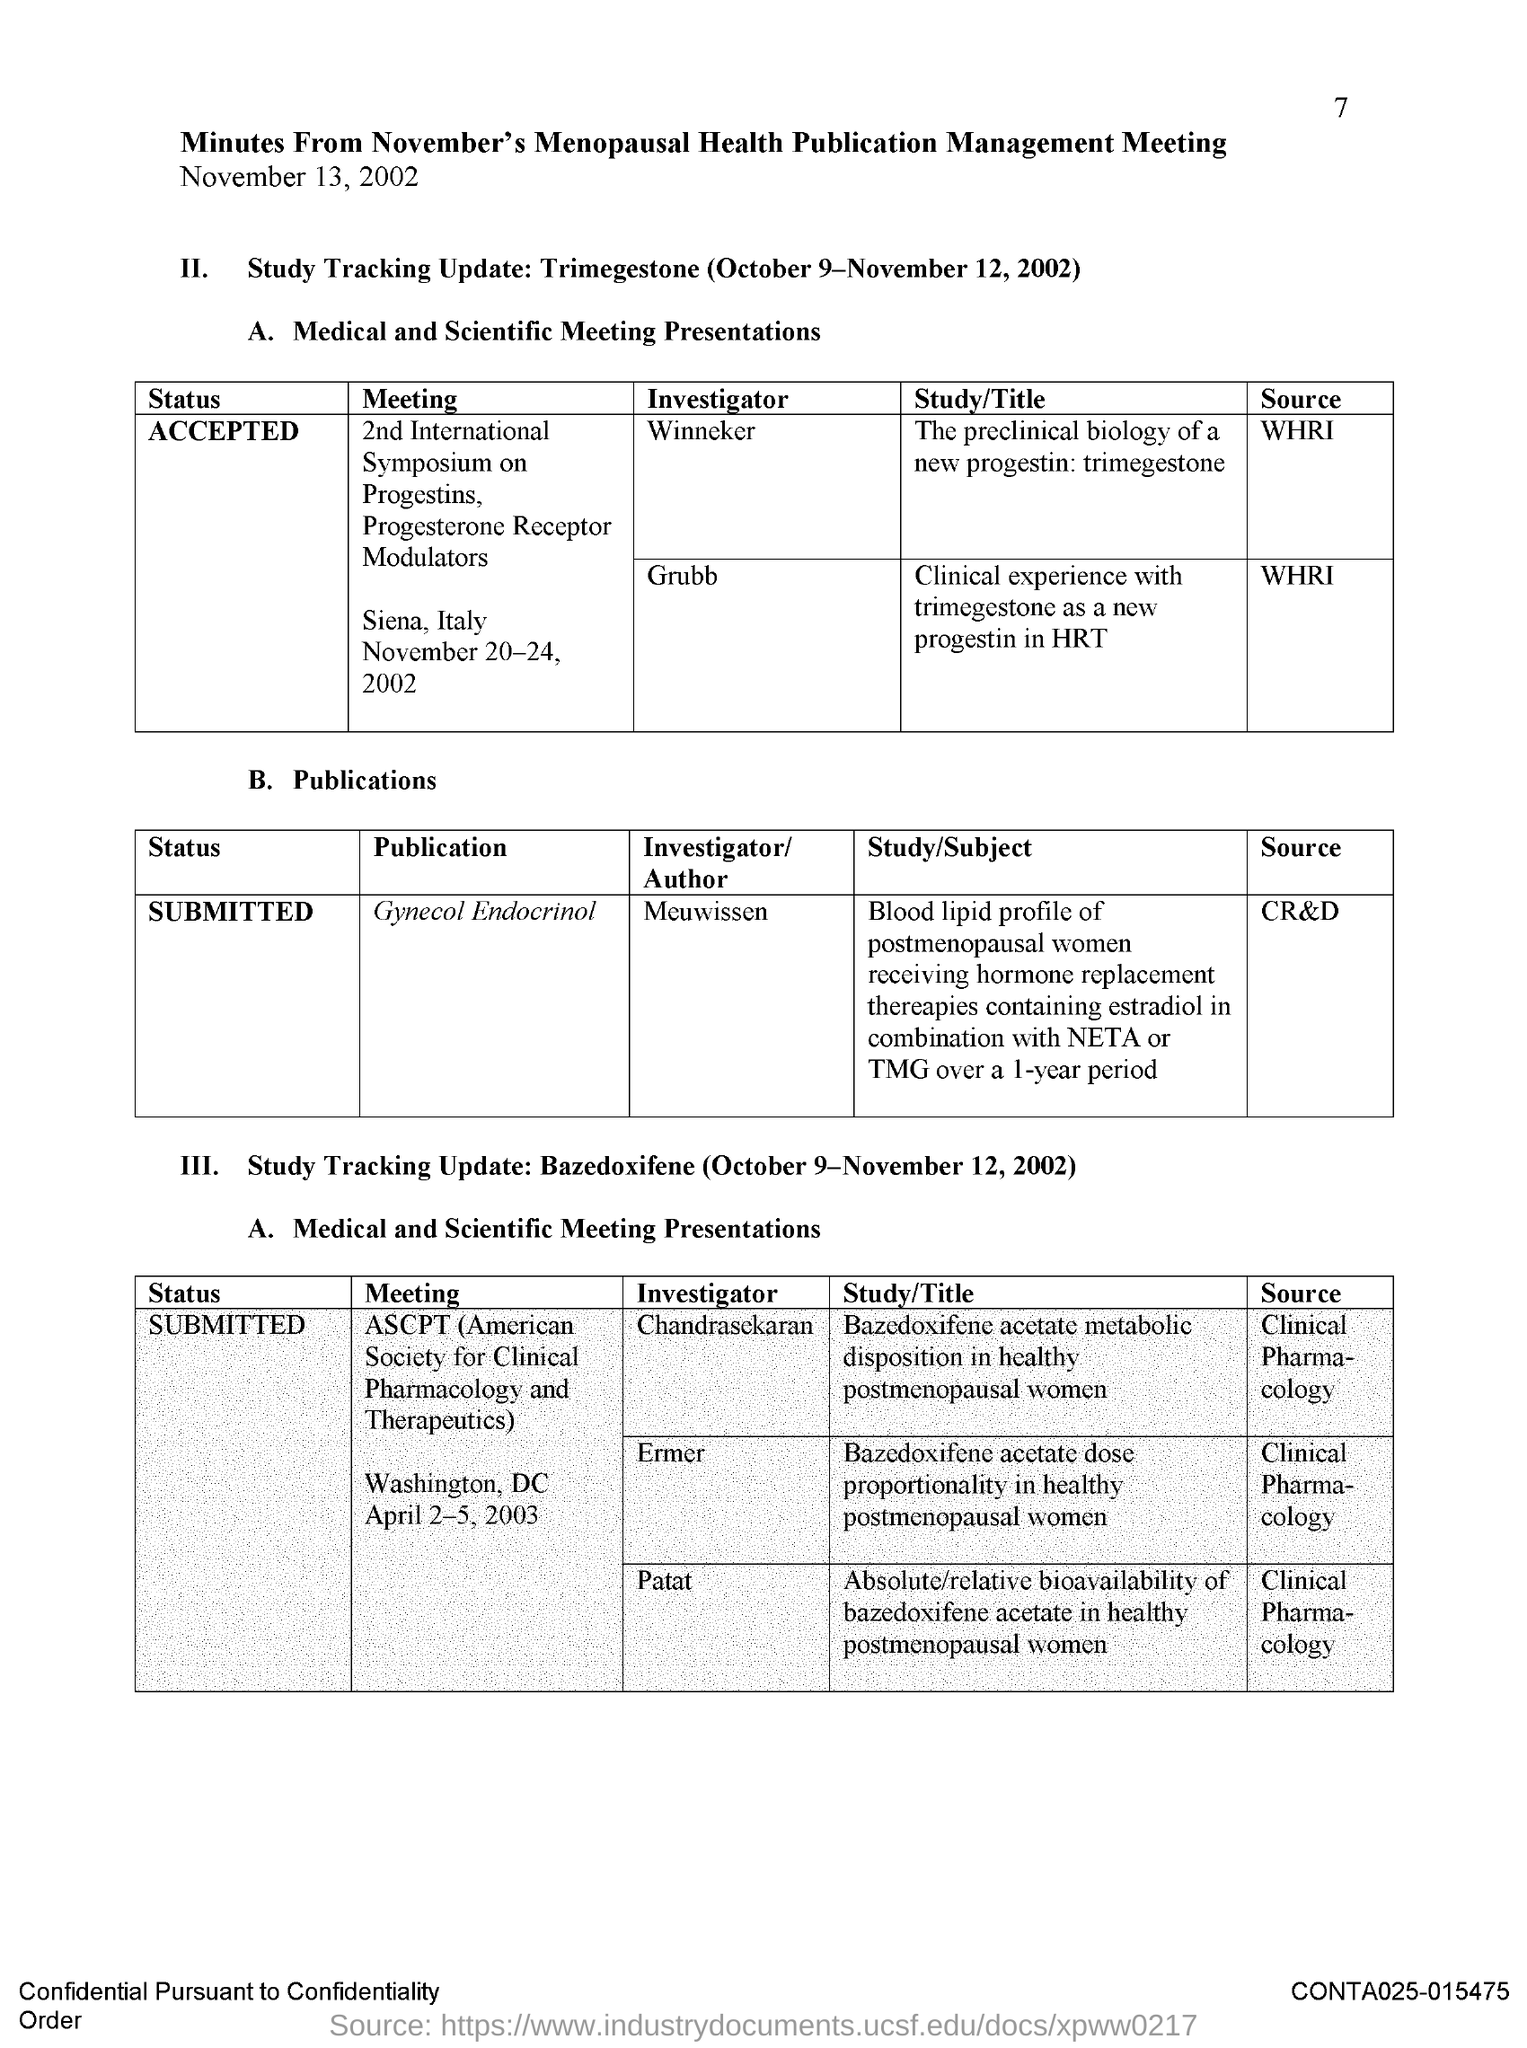What is the date on the document?
Make the answer very short. November 13, 2002. Where is the 2nd International Symposium on progestins, Progestrone Rceptor Modulators held?
Your answer should be compact. Siena, Italy. When is the 2nd International Symposium on progestins, Progestrone Rceptor Modulators held?
Ensure brevity in your answer.  November 20-24, 2002. Who is the Investigator for Gynecol Endocrinol?
Your answer should be compact. Meuwissen. Which meeting is Chandrasekaran an Investigator for?
Provide a succinct answer. ASCPT. Which meeting is Ermer an Investigator for?
Offer a terse response. ASCPT (american society for clinical pharmacology and therapeutics). Which meeting is Patat an Investigator for?
Your response must be concise. ASCPT. Where is the ASCPT meeting held?
Keep it short and to the point. Washington, dc. When is the ASCPT meeting held?
Provide a short and direct response. April 2-5, 2003. When is the study tracking update: Trimegestone for?
Offer a terse response. October 9-November 12, 2002. 